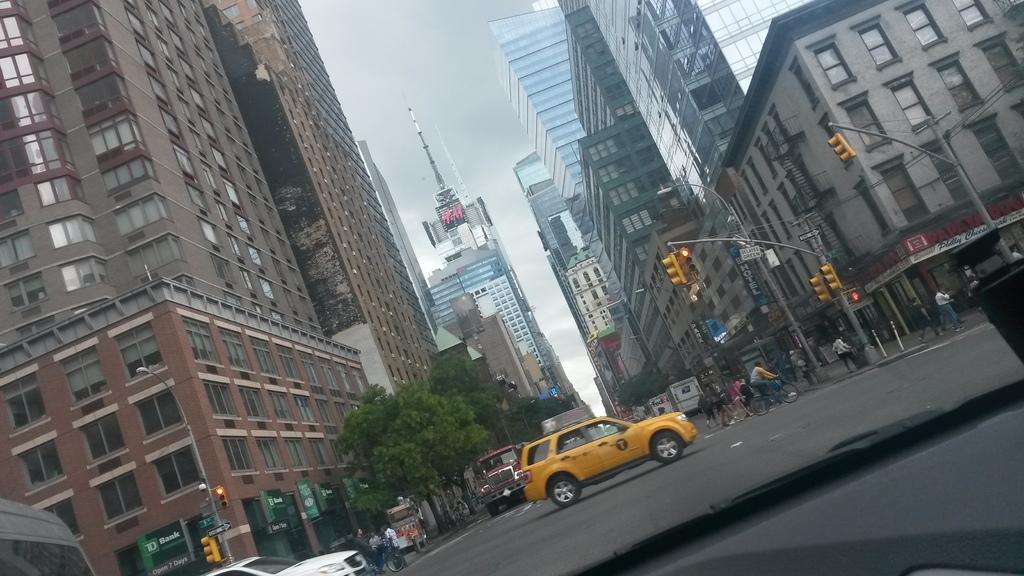Please provide a concise description of this image. In this image, we can see a glass and windshield wiper. Through the glass, we can see the other side view. Here there are so many buildings, trees, traffic signals, poles, banners, sign boards, walls, windows, tower and sky. Here we can see few vehicles are moving on the road. In this image, we can see few people. Few people are standing and walking. Few are riding vehicles. 